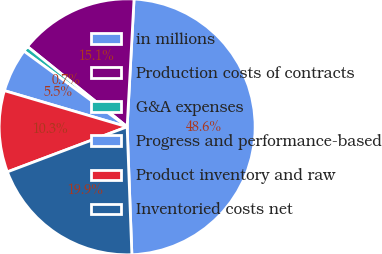<chart> <loc_0><loc_0><loc_500><loc_500><pie_chart><fcel>in millions<fcel>Production costs of contracts<fcel>G&A expenses<fcel>Progress and performance-based<fcel>Product inventory and raw<fcel>Inventoried costs net<nl><fcel>48.56%<fcel>15.07%<fcel>0.72%<fcel>5.51%<fcel>10.29%<fcel>19.86%<nl></chart> 